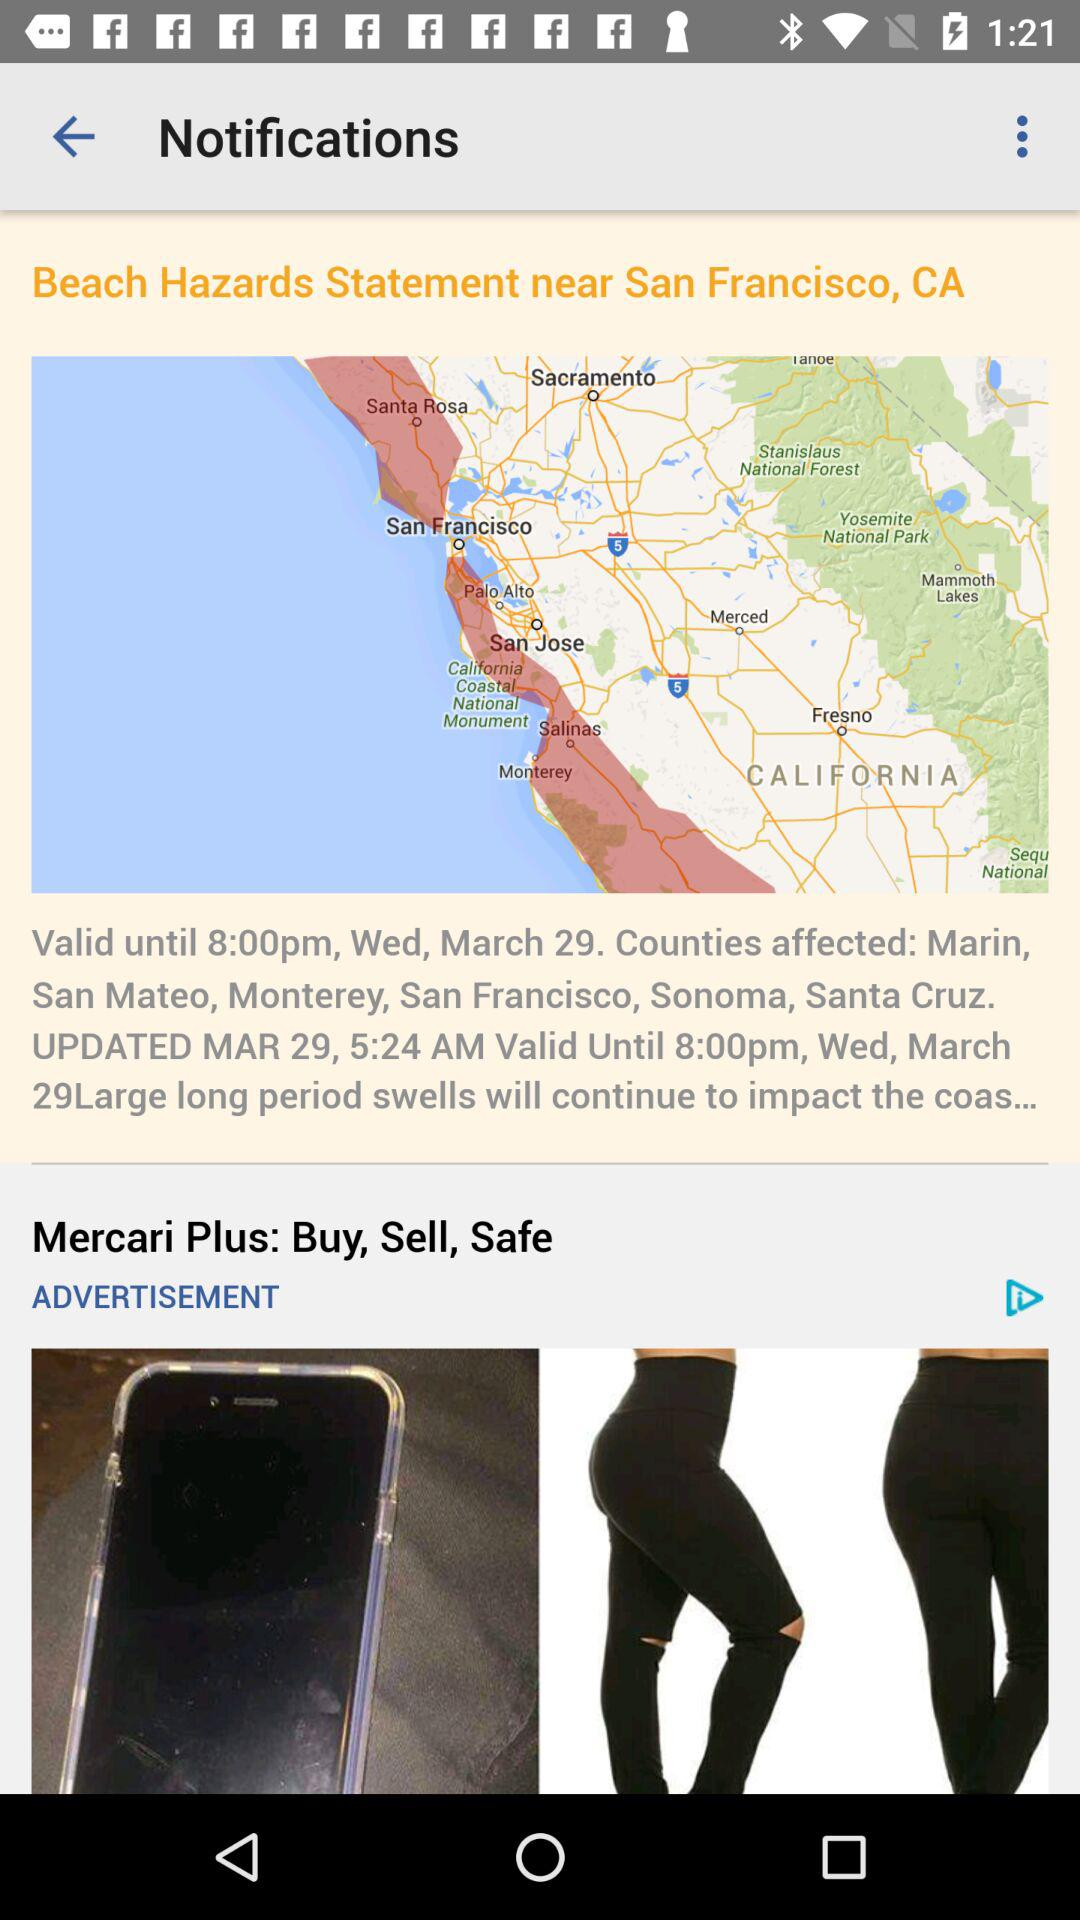What is the mentioned location in the title of the article? The mentioned location is San Francisco, CA. 